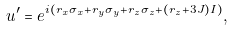Convert formula to latex. <formula><loc_0><loc_0><loc_500><loc_500>u ^ { \prime } = e ^ { i ( r _ { x } \sigma _ { x } + r _ { y } \sigma _ { y } + r _ { z } \sigma _ { z } + ( r _ { z } + 3 J ) I ) } ,</formula> 